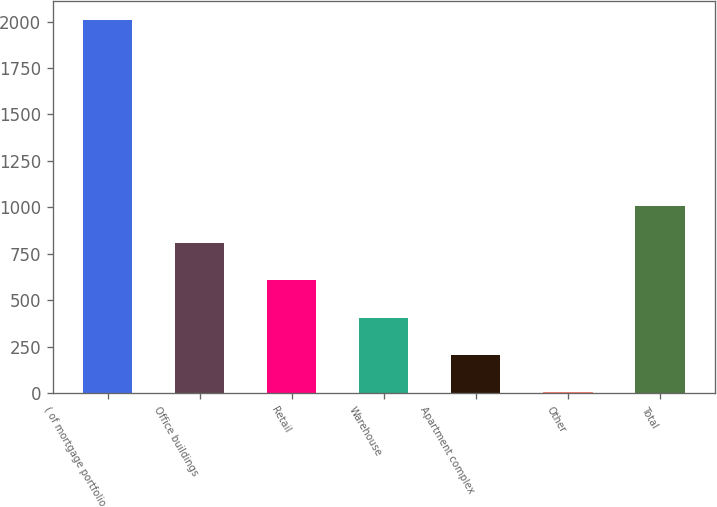<chart> <loc_0><loc_0><loc_500><loc_500><bar_chart><fcel>( of mortgage portfolio<fcel>Office buildings<fcel>Retail<fcel>Warehouse<fcel>Apartment complex<fcel>Other<fcel>Total<nl><fcel>2010<fcel>807.54<fcel>607.13<fcel>406.72<fcel>206.31<fcel>5.9<fcel>1007.95<nl></chart> 